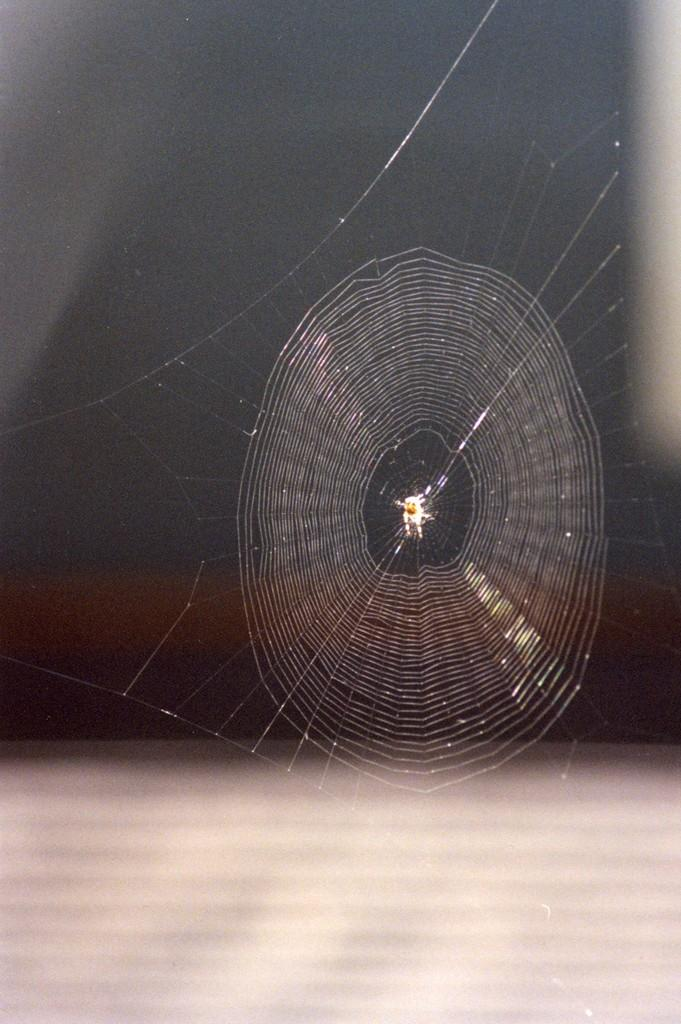What type of animal is present in the image? There is a spider in the image. Can you see a monkey riding a vessel in the image? No, there is no monkey or vessel present in the image. 